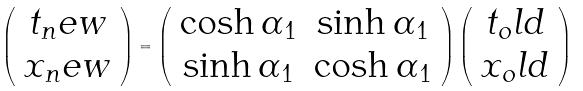<formula> <loc_0><loc_0><loc_500><loc_500>\left ( \begin{array} { c } t _ { n } e w \\ x _ { n } e w \end{array} \right ) = \left ( \begin{array} { c c } \cosh \alpha _ { 1 } & \sinh \alpha _ { 1 } \\ \sinh \alpha _ { 1 } & \cosh \alpha _ { 1 } \end{array} \right ) \left ( \begin{array} { c } t _ { o } l d \\ x _ { o } l d \end{array} \right )</formula> 